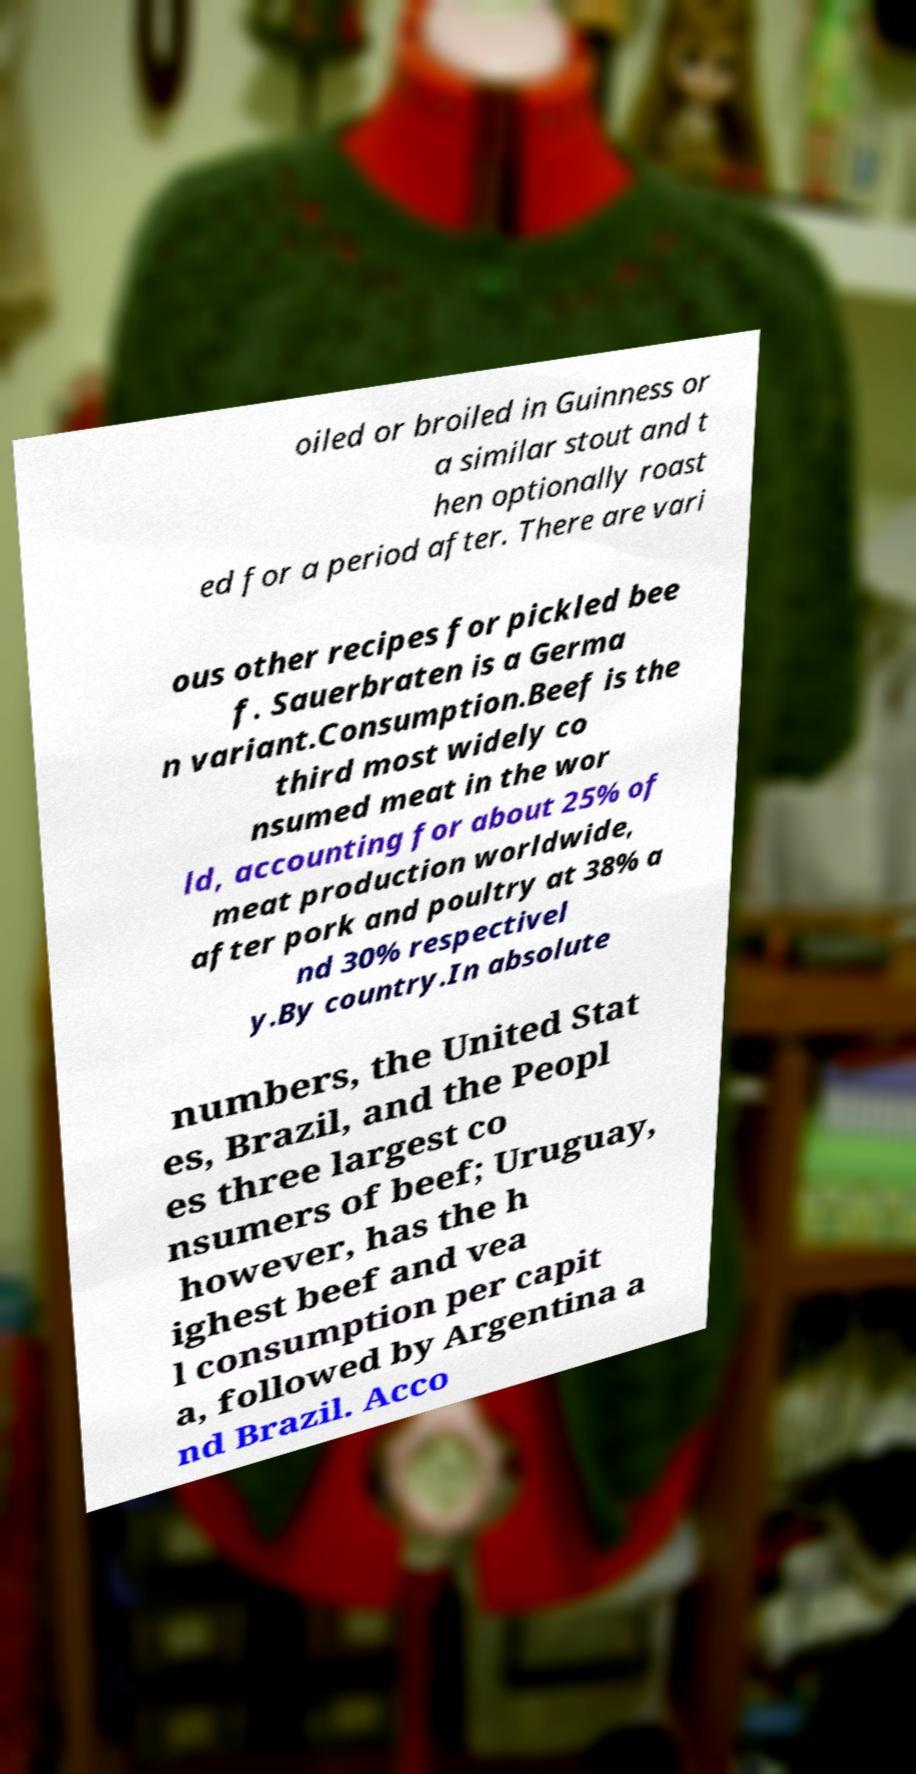I need the written content from this picture converted into text. Can you do that? oiled or broiled in Guinness or a similar stout and t hen optionally roast ed for a period after. There are vari ous other recipes for pickled bee f. Sauerbraten is a Germa n variant.Consumption.Beef is the third most widely co nsumed meat in the wor ld, accounting for about 25% of meat production worldwide, after pork and poultry at 38% a nd 30% respectivel y.By country.In absolute numbers, the United Stat es, Brazil, and the Peopl es three largest co nsumers of beef; Uruguay, however, has the h ighest beef and vea l consumption per capit a, followed by Argentina a nd Brazil. Acco 